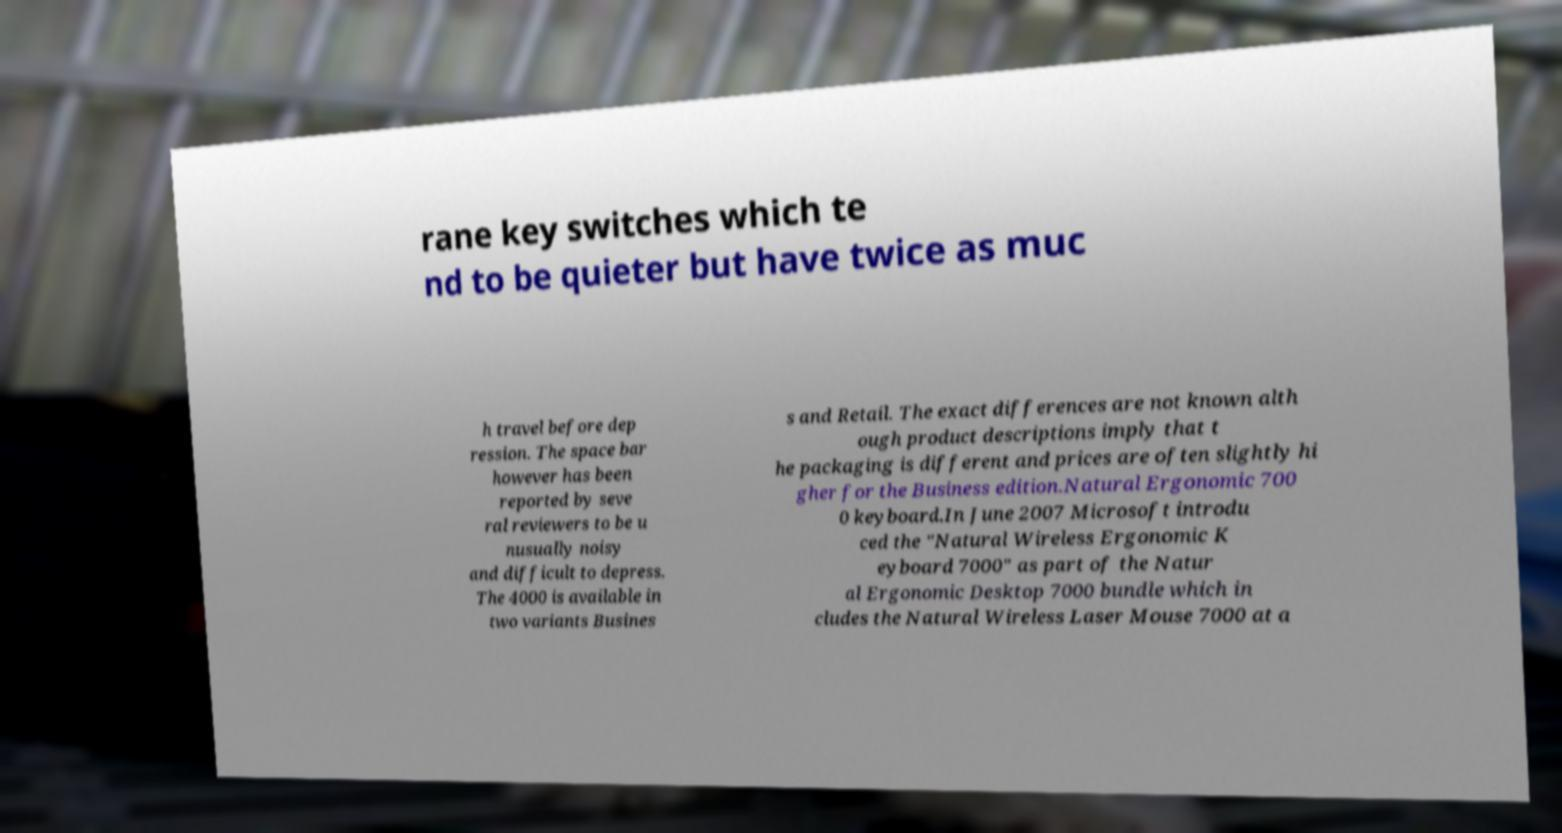Could you assist in decoding the text presented in this image and type it out clearly? rane key switches which te nd to be quieter but have twice as muc h travel before dep ression. The space bar however has been reported by seve ral reviewers to be u nusually noisy and difficult to depress. The 4000 is available in two variants Busines s and Retail. The exact differences are not known alth ough product descriptions imply that t he packaging is different and prices are often slightly hi gher for the Business edition.Natural Ergonomic 700 0 keyboard.In June 2007 Microsoft introdu ced the "Natural Wireless Ergonomic K eyboard 7000" as part of the Natur al Ergonomic Desktop 7000 bundle which in cludes the Natural Wireless Laser Mouse 7000 at a 